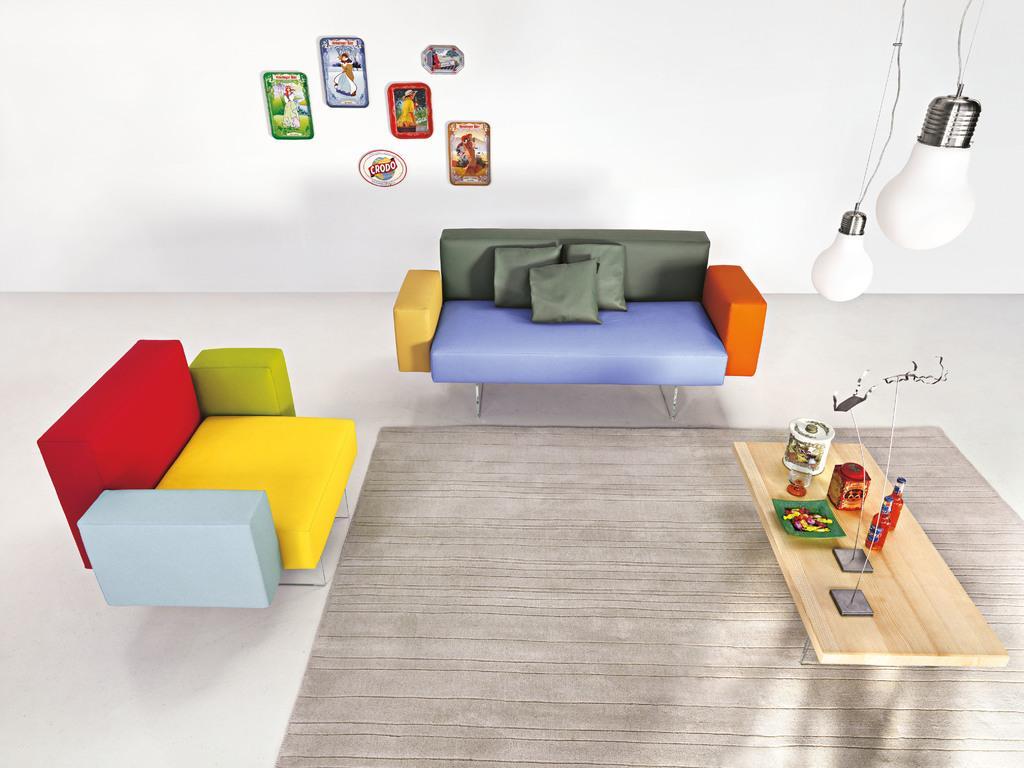In one or two sentences, can you explain what this image depicts? This couches are colorful. On this couch there are pillows. This pictures are attached on wall. This are bulbs. On a table there are bottles, jar and plate. On floor there is a carpet. 